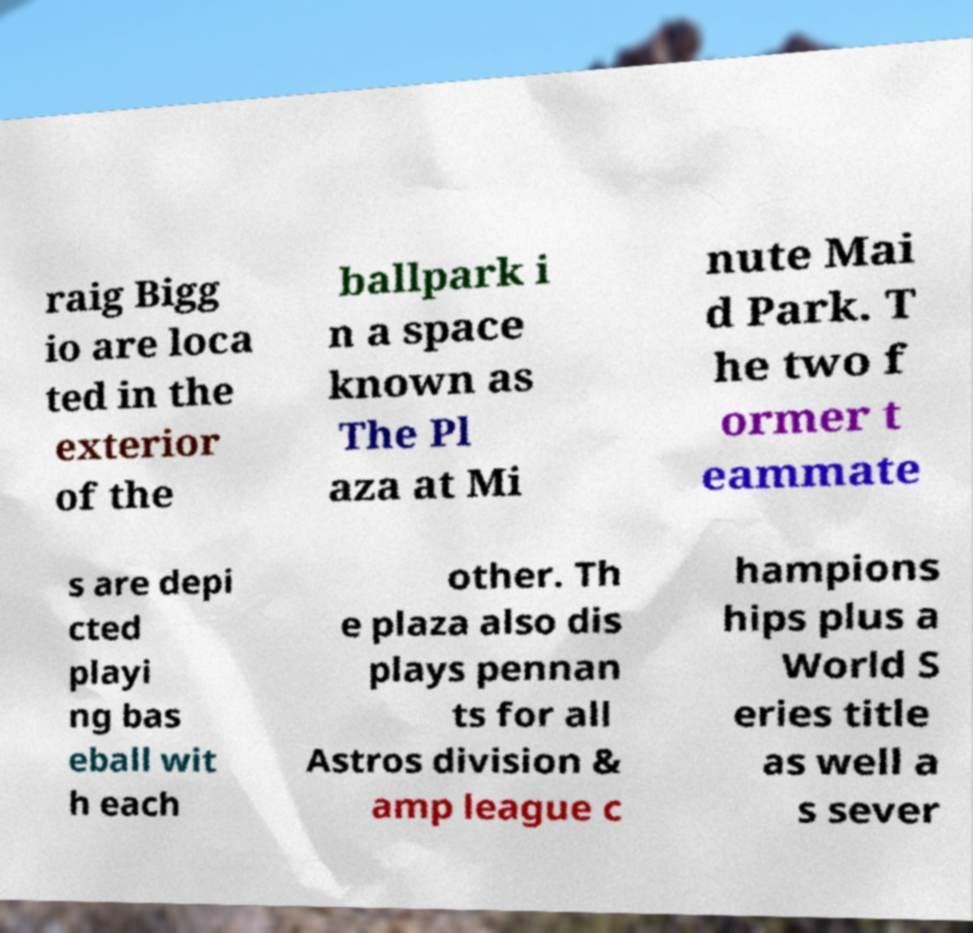Can you read and provide the text displayed in the image?This photo seems to have some interesting text. Can you extract and type it out for me? raig Bigg io are loca ted in the exterior of the ballpark i n a space known as The Pl aza at Mi nute Mai d Park. T he two f ormer t eammate s are depi cted playi ng bas eball wit h each other. Th e plaza also dis plays pennan ts for all Astros division & amp league c hampions hips plus a World S eries title as well a s sever 